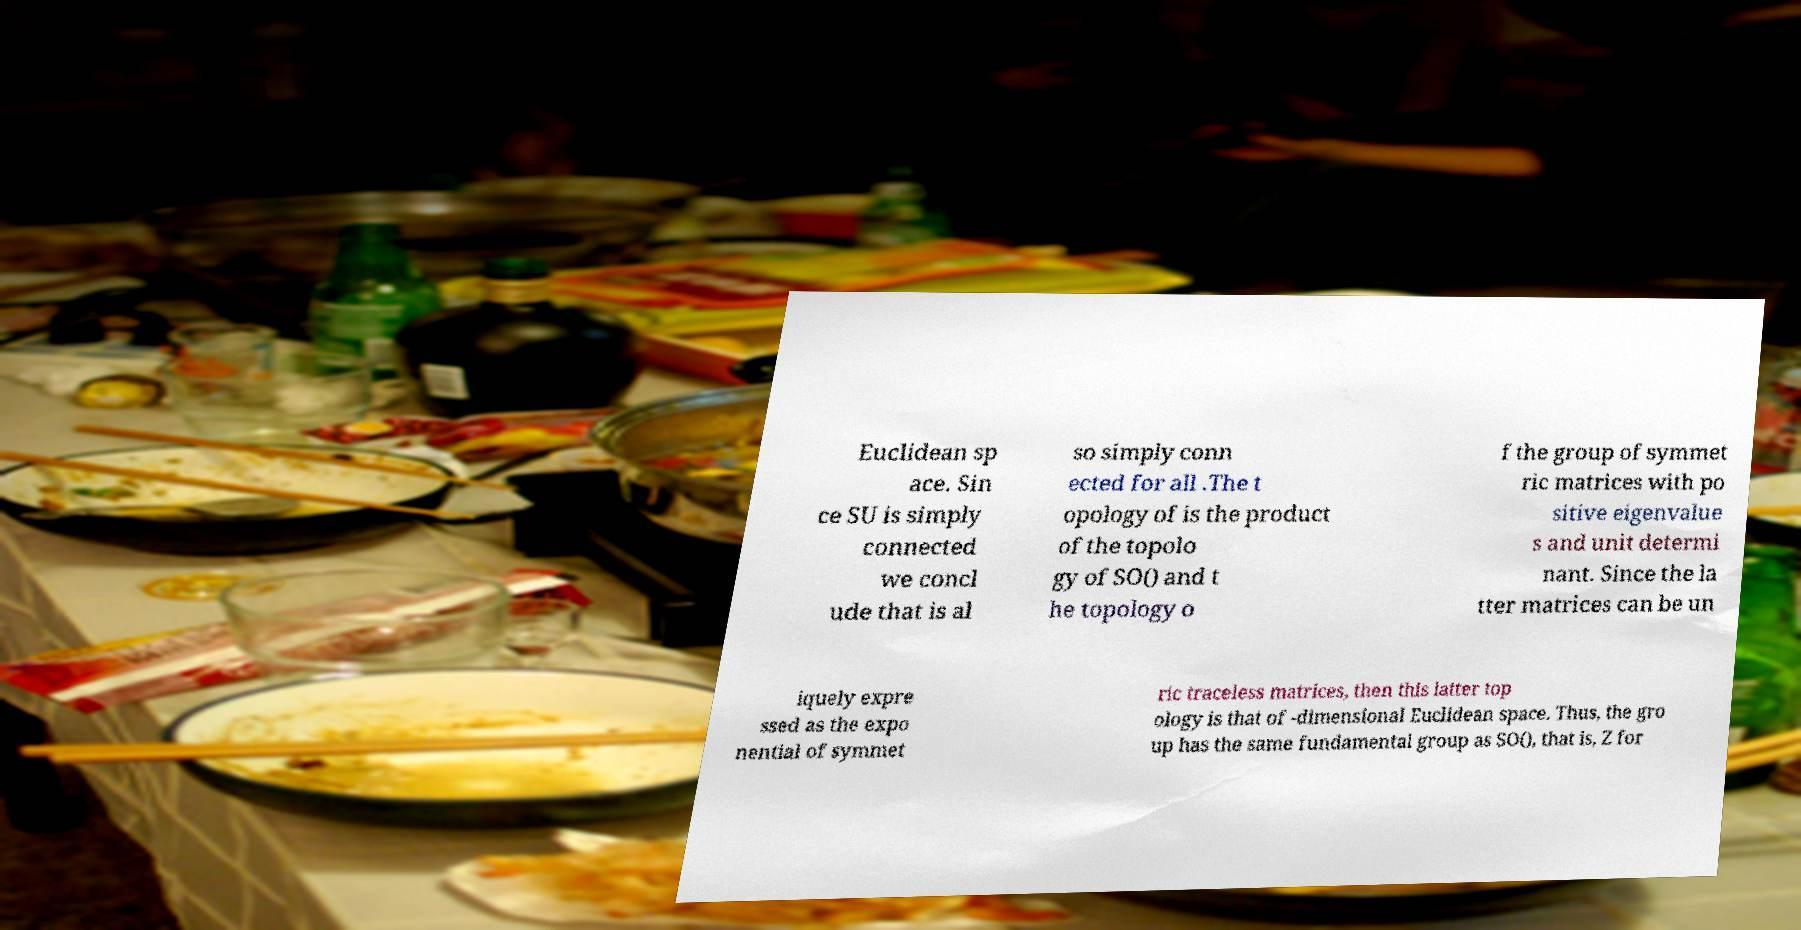For documentation purposes, I need the text within this image transcribed. Could you provide that? Euclidean sp ace. Sin ce SU is simply connected we concl ude that is al so simply conn ected for all .The t opology of is the product of the topolo gy of SO() and t he topology o f the group of symmet ric matrices with po sitive eigenvalue s and unit determi nant. Since the la tter matrices can be un iquely expre ssed as the expo nential of symmet ric traceless matrices, then this latter top ology is that of -dimensional Euclidean space. Thus, the gro up has the same fundamental group as SO(), that is, Z for 